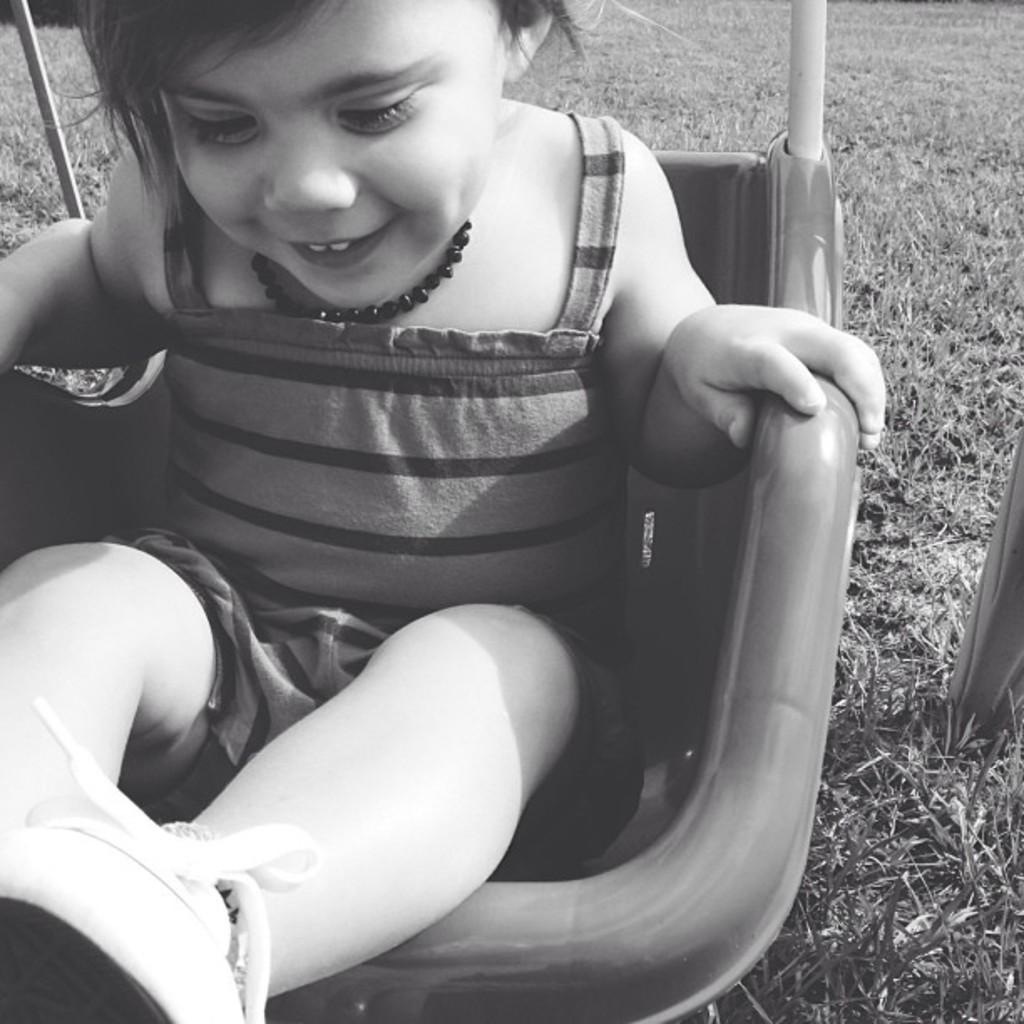Who is the main subject in the image? There is a small girl in the image. What is the girl doing in the image? The girl is sitting in a chair. What year is depicted in the image? The image does not depict a specific year; it only shows a small girl sitting in a chair. What type of sponge can be seen in the image? There is no sponge present in the image. 